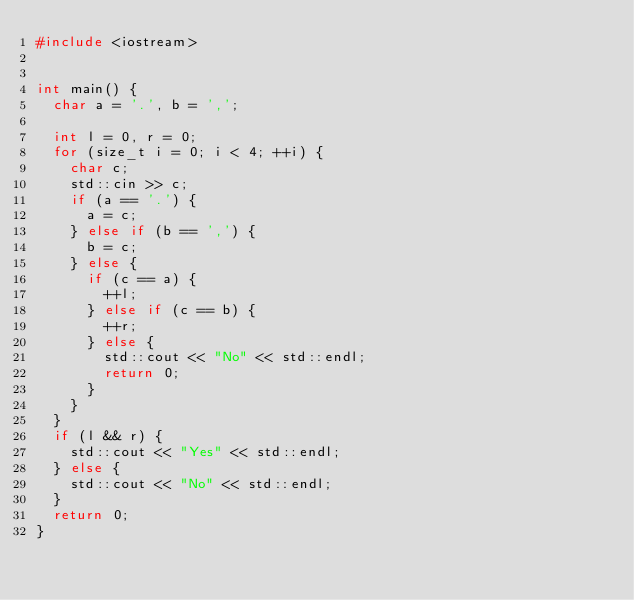<code> <loc_0><loc_0><loc_500><loc_500><_C++_>#include <iostream>


int main() {
  char a = '.', b = ',';
  
  int l = 0, r = 0;
  for (size_t i = 0; i < 4; ++i) {
    char c;
    std::cin >> c;
    if (a == '.') {
      a = c;
    } else if (b == ',') {
      b = c;
    } else {
      if (c == a) {
        ++l;
      } else if (c == b) {
        ++r;
      } else {
        std::cout << "No" << std::endl;
        return 0;
      }
    }
  }
  if (l && r) {
    std::cout << "Yes" << std::endl;
  } else {
    std::cout << "No" << std::endl;
  }
  return 0;
}
</code> 